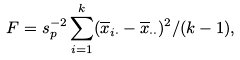Convert formula to latex. <formula><loc_0><loc_0><loc_500><loc_500>F = s _ { p } ^ { - 2 } \sum _ { i = 1 } ^ { k } ( \overline { x } _ { i \cdot } - \overline { x } _ { \cdot \cdot } ) ^ { 2 } / ( k - 1 ) ,</formula> 